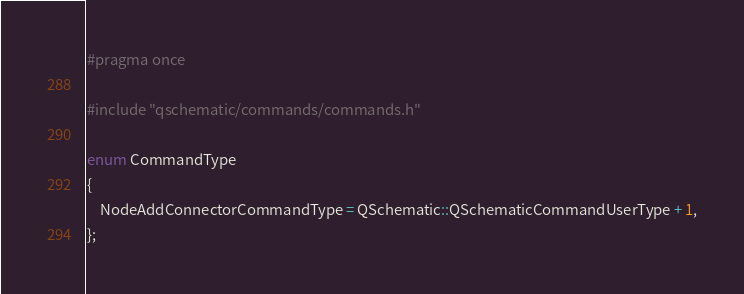Convert code to text. <code><loc_0><loc_0><loc_500><loc_500><_C_>#pragma once

#include "qschematic/commands/commands.h"

enum CommandType
{
    NodeAddConnectorCommandType = QSchematic::QSchematicCommandUserType + 1,
};
</code> 